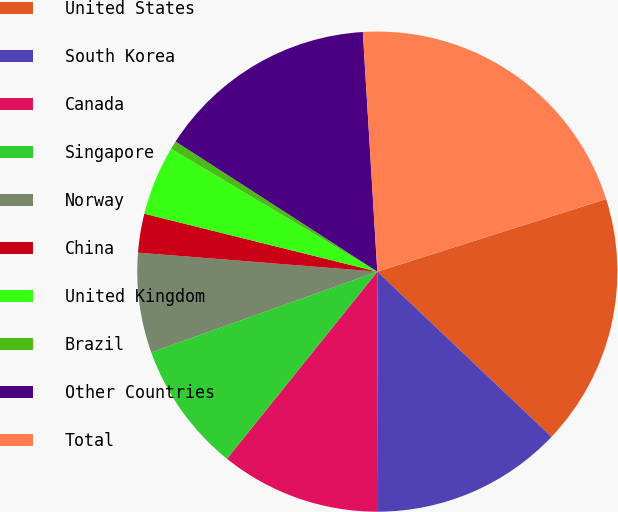Convert chart to OTSL. <chart><loc_0><loc_0><loc_500><loc_500><pie_chart><fcel>United States<fcel>South Korea<fcel>Canada<fcel>Singapore<fcel>Norway<fcel>China<fcel>United Kingdom<fcel>Brazil<fcel>Other Countries<fcel>Total<nl><fcel>16.97%<fcel>12.87%<fcel>10.82%<fcel>8.77%<fcel>6.72%<fcel>2.62%<fcel>4.67%<fcel>0.57%<fcel>14.92%<fcel>21.07%<nl></chart> 